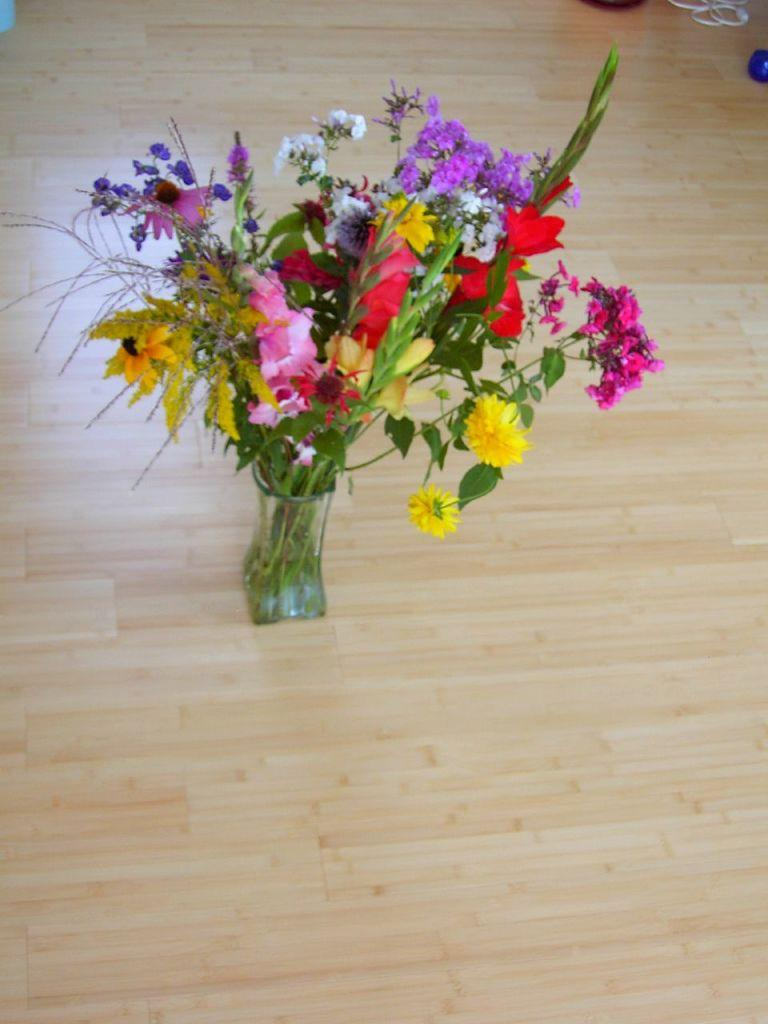What is the main object in the image? There is a flower vase in the image. Where is the flower vase located? The flower vase is on the wooden floor. What can be seen behind the flower vase? There are objects visible behind the flower vase. What is the purpose of the sneeze in the image? There is no sneeze present in the image, so it cannot have a purpose within the context of the image. 